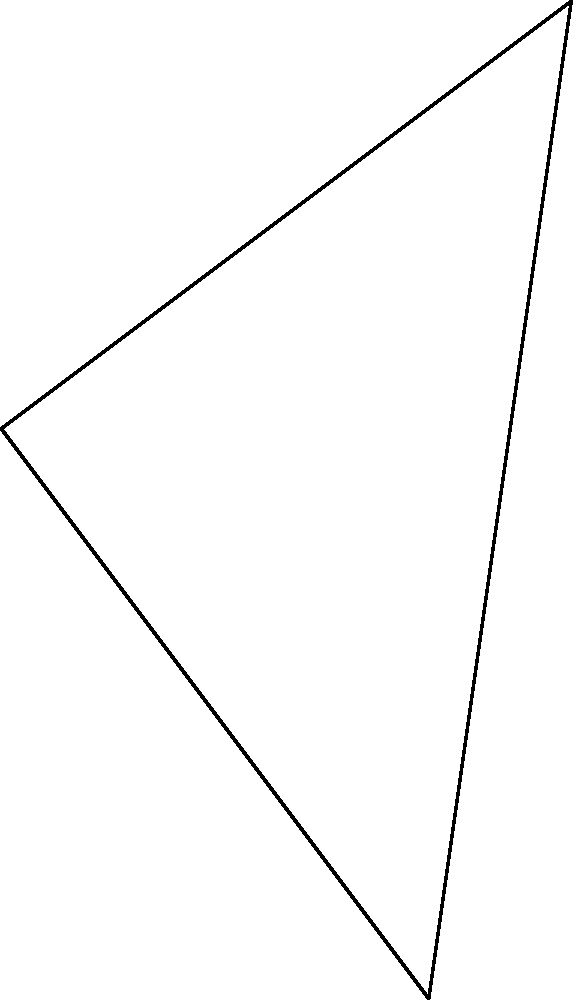Using the sky map provided, calculate the angle $\theta$ between two celestial bodies, Star A and Star B, as observed from Earth. The angle between Earth and Star A is $60°$, and the angle between Earth and Star B is $80°$. Use the law of cosines to find $\theta$ to the nearest degree. To solve this problem, we'll use the law of cosines for spherical triangles. The steps are as follows:

1) The law of cosines for spherical triangles states:
   $\cos(c) = \cos(a)\cos(b) + \sin(a)\sin(b)\cos(C)$

   Where $a$, $b$, and $c$ are the sides of the spherical triangle, and $C$ is the angle opposite to side $c$.

2) In our case:
   $a = 60°$
   $b = 80°$
   $C = \theta$ (the angle we're looking for)

3) Substituting these into the formula:
   $\cos(c) = \cos(60°)\cos(80°) + \sin(60°)\sin(80°)\cos(\theta)$

4) We want to solve for $\theta$, so let's rearrange the equation:
   $\cos(\theta) = \frac{\cos(c) - \cos(60°)\cos(80°)}{\sin(60°)\sin(80°)}$

5) Now we need to calculate $\cos(c)$. We can do this using the Euclidean distance formula and then normalizing:
   $\cos(c) = \frac{80 \cdot 60 + 60 \cdot (-80)}{\sqrt{80^2 + 60^2} \cdot \sqrt{60^2 + (-80)^2}} = -0.1283$

6) Now we can substitute all values:
   $\cos(\theta) = \frac{-0.1283 - \cos(60°)\cos(80°)}{\sin(60°)\sin(80°)}$

7) Calculate:
   $\cos(\theta) = \frac{-0.1283 - (0.5)(0.1736)}{(0.8660)(0.9848)} = -0.2098$

8) To get $\theta$, we take the inverse cosine (arccos):
   $\theta = \arccos(-0.2098) \approx 102.1°$

9) Rounding to the nearest degree:
   $\theta \approx 102°$
Answer: $102°$ 